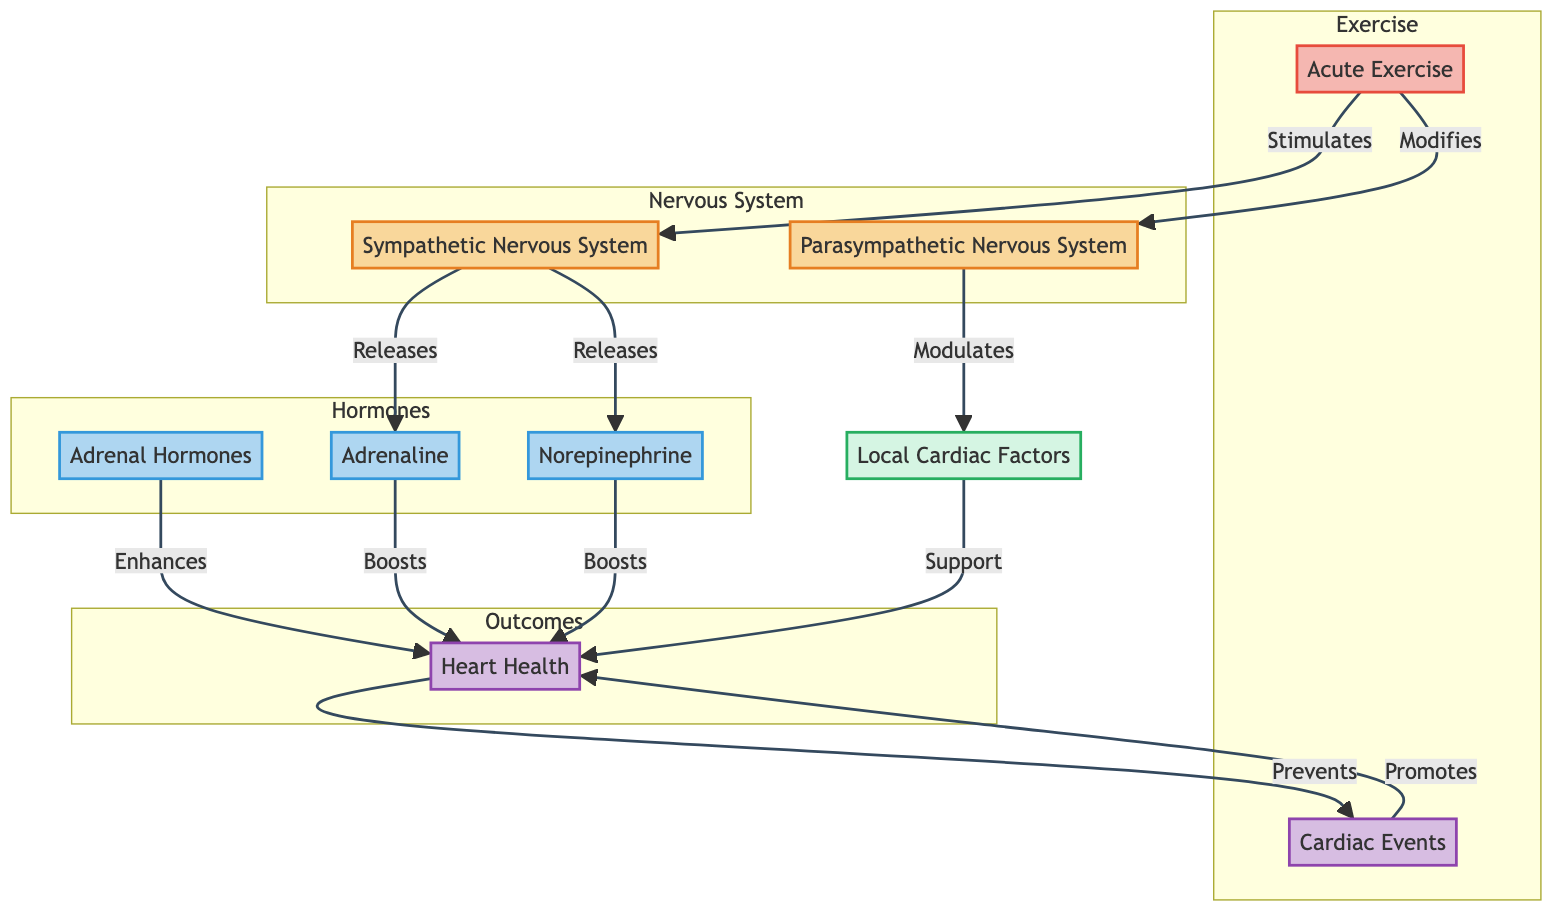What are the two branches of the nervous system shown in the diagram? The diagram highlights the Sympathetic Nervous System and the Parasympathetic Nervous System as the two branches of the nervous system involved in neurohormonal regulation.
Answer: Sympathetic Nervous System, Parasympathetic Nervous System Which hormones are involved in this integrative model? The hormones included in the diagram are Adrenal Hormones, Adrenaline, and Norepinephrine. These are displayed in the "Hormones" section of the flowchart.
Answer: Adrenal Hormones, Adrenaline, Norepinephrine How does acute exercise influence the sympathetic nervous system? Acute Exercise stimulates the Sympathetic Nervous System as depicted in the diagram, establishing a direct relationship between these two components.
Answer: Stimulates What is the collective role of local cardiac factors in relation to heart health? Local cardiac factors support heart health according to the diagram, highlighting their positive contribution in the context of the neurohormonal regulation model.
Answer: Support How do adrenal hormones affect heart health? The diagram indicates that adrenal hormones enhance heart health, showing their beneficial role in the overall integrative model during exercise.
Answer: Enhances Which factors prevent cardiac events according to the diagram? Heart Health serves to prevent Cardiac Events, as shown by the directional flow from the heart health node to cardiac events in the diagram.
Answer: Heart Health What is the relationship between chronic exercise and heart health? Chronic Exercise promotes heart health, indicating a beneficial effect over time within the integrative model outlined in the diagram.
Answer: Promotes How many components are in the "Hormones" subgraph? The "Hormones" subgraph contains three components, which are Adrenal Hormones, Adrenaline, and Norepinephrine as depicted in the diagram.
Answer: Three What role does acute exercise play in modulating the parasympathetic nervous system? Acute Exercise modifies the Parasympathetic Nervous System, demonstrating an interactive effect in the context of exercise-induced responses.
Answer: Modifies 